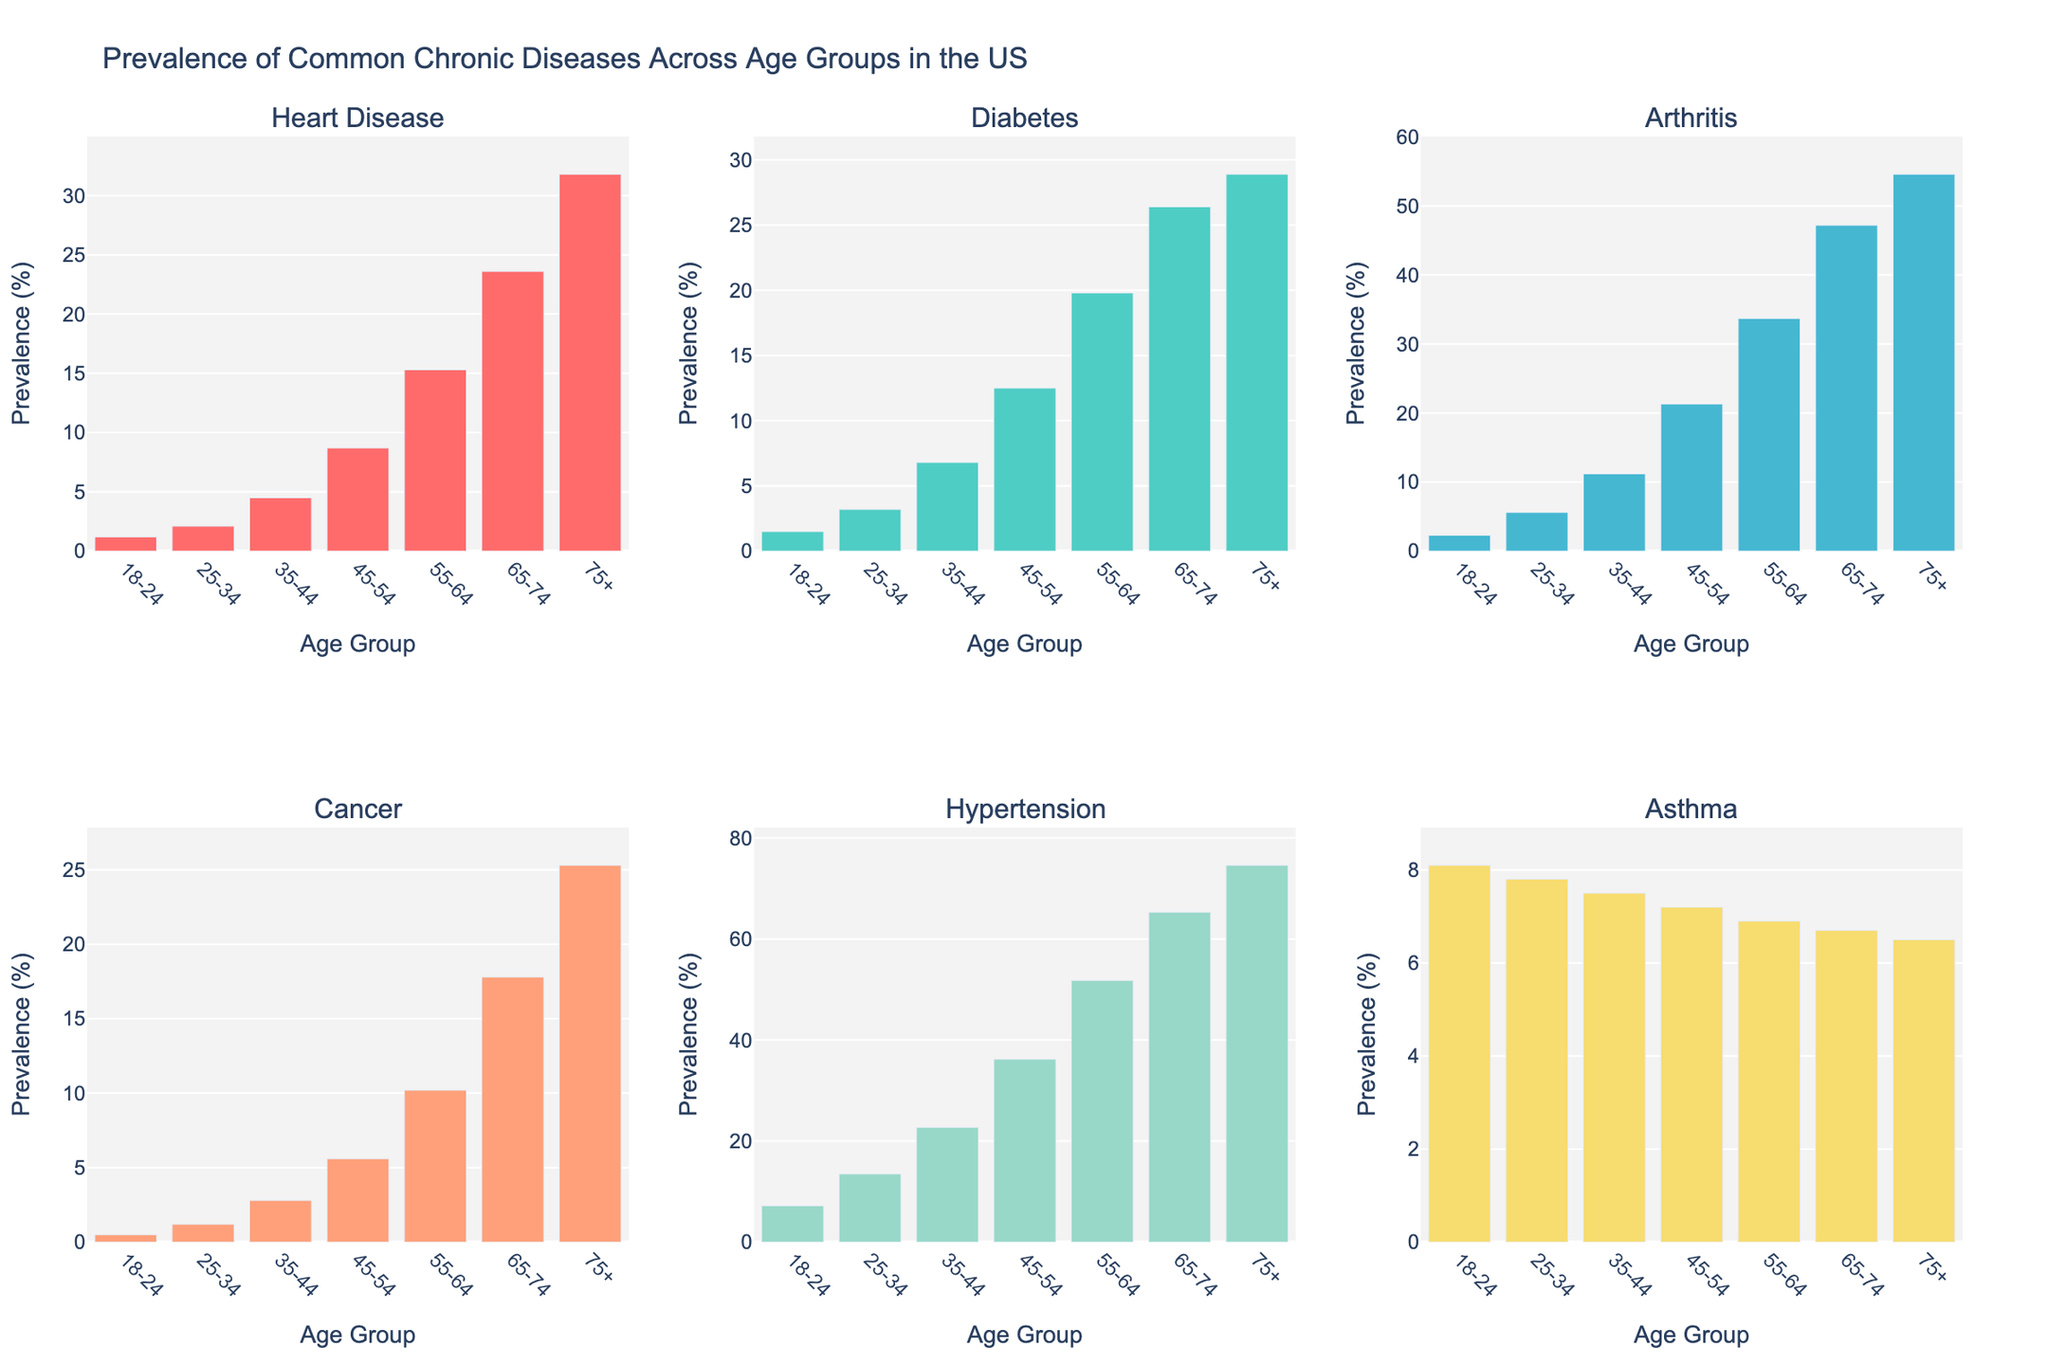Which age group has the highest prevalence of heart disease? By observing the height of the bars in the heart disease subplot, the age group 75+ has the highest prevalence.
Answer: 75+ What is the difference in the prevalence of diabetes between the 35-44 and 65-74 age groups? The prevalence of diabetes in the 35-44 age group is 6.8%, and in the 65-74 age group is 26.4%. The difference is 26.4% - 6.8%.
Answer: 19.6% Which disease has the highest prevalence in the 25-34 age group? By comparing the heights of the bars for the 25-34 age group in each subplot, hypertension has the highest prevalence in this age group.
Answer: Hypertension How does the prevalence of arthritis change from the 18-24 age group to the 75+ age group? The prevalence of arthritis in the 18-24 age group is 2.3%, and in the 75+ age group is 54.6%. The change is 54.6% - 2.3%.
Answer: Increased by 52.3% What is the average prevalence of cancer across all age groups? Sum the prevalence rates of cancer for all age groups and divide by the number of age groups. (0.5 + 1.2 + 2.8 + 5.6 + 10.2 + 17.8 + 25.3) / 7
Answer: 9.2% Which age group shows a decline in asthma prevalence compared to the previous age group? Comparing the heights of the bars for asthma in consecutive age groups, the 45-54, 55-64, 65-74, and 75+ age groups show a decline compared to the previous age group.
Answer: 45-54, 55-64, 65-74, 75+ Is the prevalence of hypertension higher in the 55-64 age group or the 18-24 age group? The height of the bar for hypertension in the 55-64 age group is much higher than in the 18-24 age group.
Answer: 55-64 Which chronic disease has a consistently decreasing trend as age increases? By observing all the subplots, only asthma shows a decreasing trend as age increases.
Answer: Asthma 